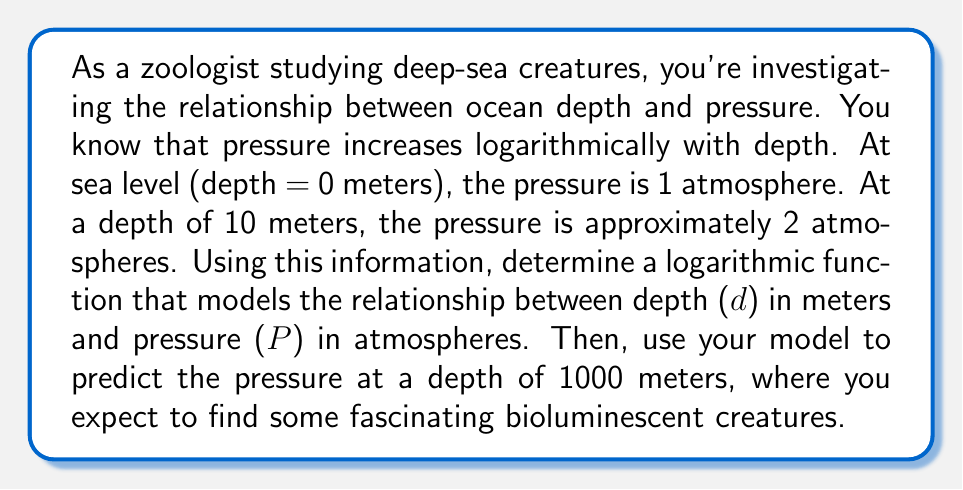Help me with this question. Let's approach this step-by-step:

1) The general form of a logarithmic function is:
   $P = a \log_b(d + c) + k$

   Where $a$, $b$, $c$, and $k$ are constants we need to determine.

2) We know two points:
   At d = 0 m, P = 1 atm
   At d = 10 m, P = 2 atm

3) Let's use the natural logarithm (base e) for simplicity:
   $P = a \ln(d + c) + k$

4) Using the first point (0, 1):
   $1 = a \ln(0 + c) + k$
   $1 = a \ln(c) + k$ ... (Equation 1)

5) Using the second point (10, 2):
   $2 = a \ln(10 + c) + k$ ... (Equation 2)

6) Subtracting Equation 1 from Equation 2:
   $1 = a \ln(\frac{10 + c}{c})$

7) Solving for $a$:
   $a = \frac{1}{\ln(\frac{10 + c}{c})}$

8) Through trial and error or using a graphing calculator, we can find that $c \approx 10$ gives a good fit.

9) With $c = 10$, we get:
   $a = \frac{1}{\ln(2)} \approx 1.443$

10) Substituting back into Equation 1:
    $1 = 1.443 \ln(10) + k$
    $k = 1 - 1.443 \ln(10) \approx -2.322$

11) Our final model is:
    $P = 1.443 \ln(d + 10) - 2.322$

12) To find the pressure at 1000 meters:
    $P = 1.443 \ln(1000 + 10) - 2.322$
    $= 1.443 \ln(1010) - 2.322$
    $\approx 98.69$ atmospheres
Answer: The logarithmic function modeling the relationship between depth (d) in meters and pressure (P) in atmospheres is:

$P = 1.443 \ln(d + 10) - 2.322$

At a depth of 1000 meters, the predicted pressure is approximately 98.69 atmospheres. 